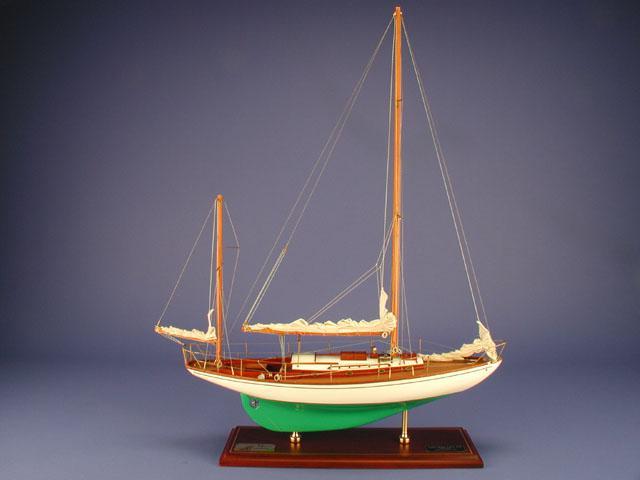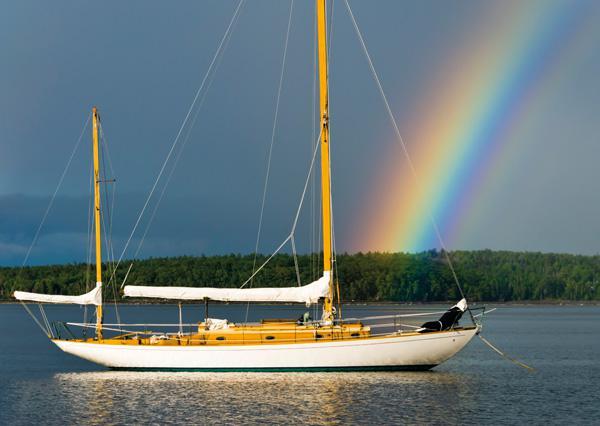The first image is the image on the left, the second image is the image on the right. Assess this claim about the two images: "One image shows a boat that is not in a body of water.". Correct or not? Answer yes or no. Yes. 